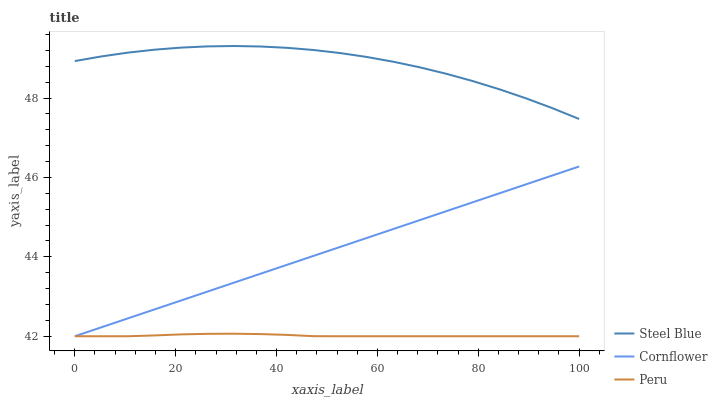Does Peru have the minimum area under the curve?
Answer yes or no. Yes. Does Steel Blue have the maximum area under the curve?
Answer yes or no. Yes. Does Steel Blue have the minimum area under the curve?
Answer yes or no. No. Does Peru have the maximum area under the curve?
Answer yes or no. No. Is Cornflower the smoothest?
Answer yes or no. Yes. Is Steel Blue the roughest?
Answer yes or no. Yes. Is Peru the smoothest?
Answer yes or no. No. Is Peru the roughest?
Answer yes or no. No. Does Cornflower have the lowest value?
Answer yes or no. Yes. Does Steel Blue have the lowest value?
Answer yes or no. No. Does Steel Blue have the highest value?
Answer yes or no. Yes. Does Peru have the highest value?
Answer yes or no. No. Is Peru less than Steel Blue?
Answer yes or no. Yes. Is Steel Blue greater than Peru?
Answer yes or no. Yes. Does Cornflower intersect Peru?
Answer yes or no. Yes. Is Cornflower less than Peru?
Answer yes or no. No. Is Cornflower greater than Peru?
Answer yes or no. No. Does Peru intersect Steel Blue?
Answer yes or no. No. 